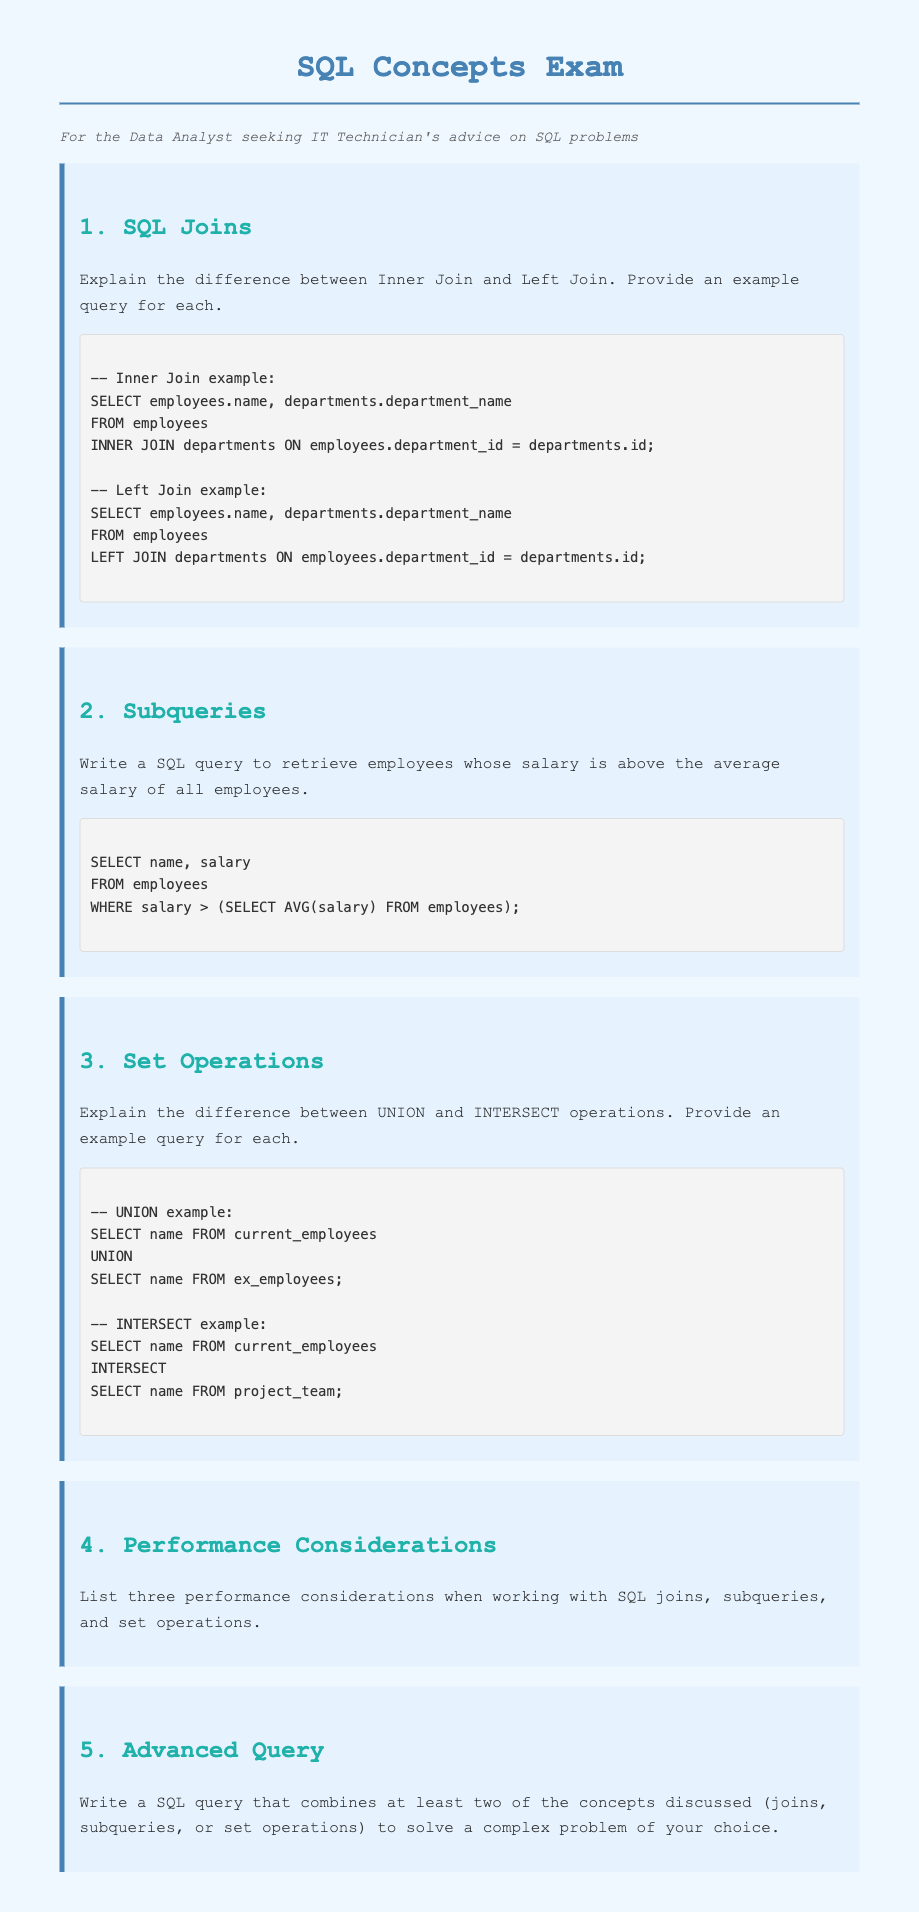What is the title of the document? The title of the document is found in the head section and indicates the main topic of the content, which is SQL Concepts Exam.
Answer: SQL Concepts Exam How many main topics are covered in the questions? The questions explore several SQL concepts, which can be counted from the questions section; there are five main topics.
Answer: 5 What SQL operation is used in the provided Left Join example? The SQL operation is described in the second question under SQL Joins, showcasing the use of the Left Join which emphasizes including all records from the left table.
Answer: Left Join What is the purpose of the subquery in question 2? The subquery is utilized to calculate the average salary among employees for comparing individual salaries, allowing focused retrieval.
Answer: Calculate average salary Which SQL operation combines results from two result sets to remove duplicates? The document describes this operation as "UNION," specifically mentioned in the Set Operations section for combining current and ex-employees.
Answer: UNION What is one key performance consideration mentioned in the performance considerations section? The document lists performance considerations though not explicitly detailed; it implies considerations like execution time or resource management while using joins, subqueries, and set operations.
Answer: Execution time In which section do you find an explanation of Inner Join and Left Join? The explanations of these joins are found in the first question of the document, focusing specifically on SQL Joins.
Answer: SQL Joins What SQL clause is used to filter records based on a condition? The document presents the WHERE clause as crucial for determining which records meet specific conditions, particularly in the subquery example.
Answer: WHERE clause 